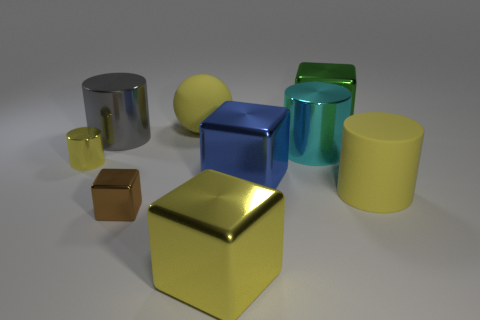The green cube that is the same material as the small cylinder is what size?
Your answer should be compact. Large. Are there any big metal objects behind the large ball?
Your answer should be very brief. Yes. There is a large metal object behind the large gray metal thing; is there a yellow sphere that is behind it?
Your answer should be compact. No. Is the size of the yellow metal object right of the gray cylinder the same as the yellow metal object left of the small brown thing?
Your response must be concise. No. How many tiny objects are rubber balls or yellow blocks?
Give a very brief answer. 0. The yellow object to the right of the shiny block that is behind the small yellow metal cylinder is made of what material?
Your answer should be very brief. Rubber. The big shiny object that is the same color as the sphere is what shape?
Keep it short and to the point. Cube. Is there a brown thing that has the same material as the small cylinder?
Your answer should be compact. Yes. Are the blue thing and the yellow thing that is right of the yellow block made of the same material?
Keep it short and to the point. No. What is the color of the rubber cylinder that is the same size as the green metal cube?
Offer a very short reply. Yellow. 